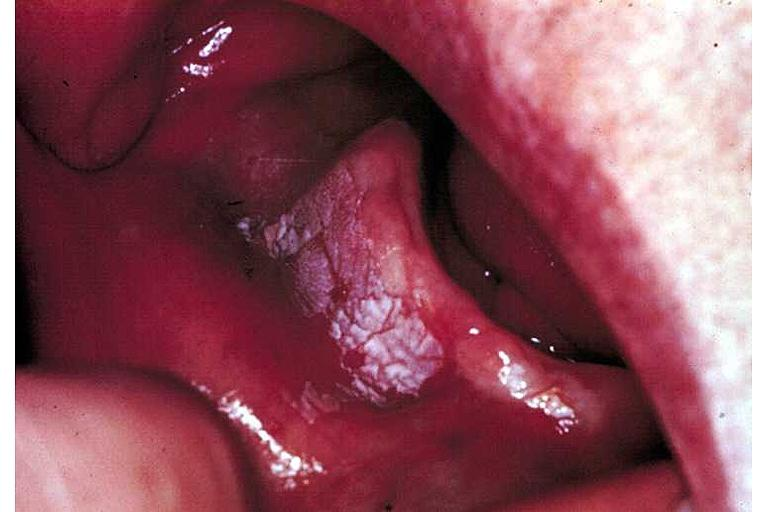s intramural one lesion present?
Answer the question using a single word or phrase. No 